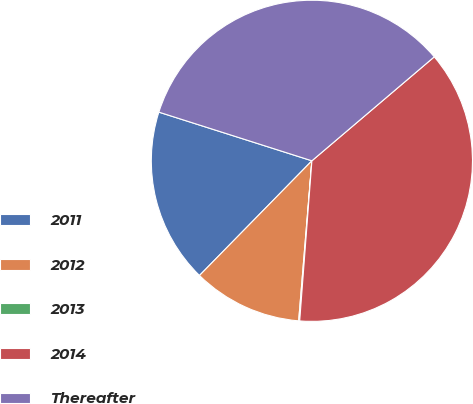Convert chart to OTSL. <chart><loc_0><loc_0><loc_500><loc_500><pie_chart><fcel>2011<fcel>2012<fcel>2013<fcel>2014<fcel>Thereafter<nl><fcel>17.56%<fcel>11.03%<fcel>0.1%<fcel>37.42%<fcel>33.89%<nl></chart> 